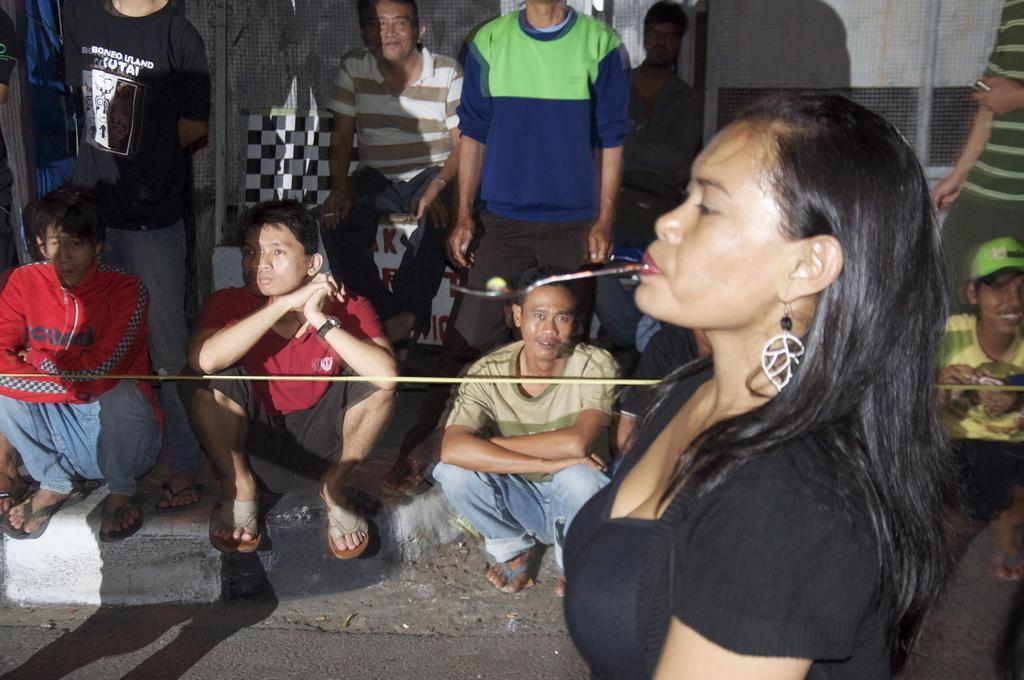Can you describe this image briefly? In the image I can a lady who is holding something with the mouth and to the side there are some people, among them some are sitting on the floor. 